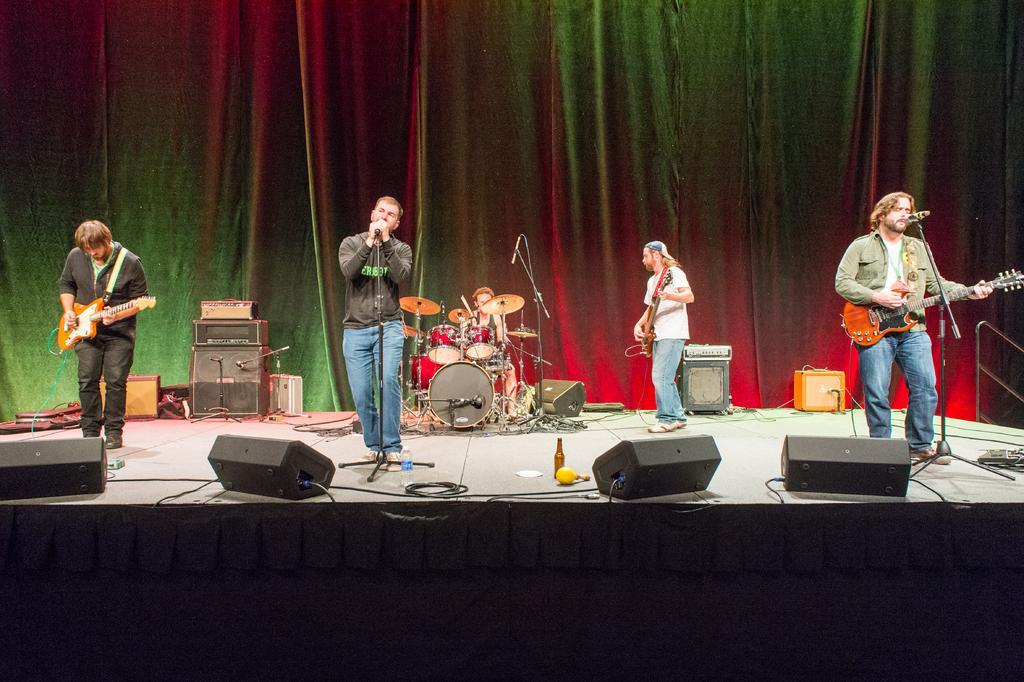In one or two sentences, can you explain what this image depicts? Two persons are playing the guitar and a person is singing a song in the middle. 